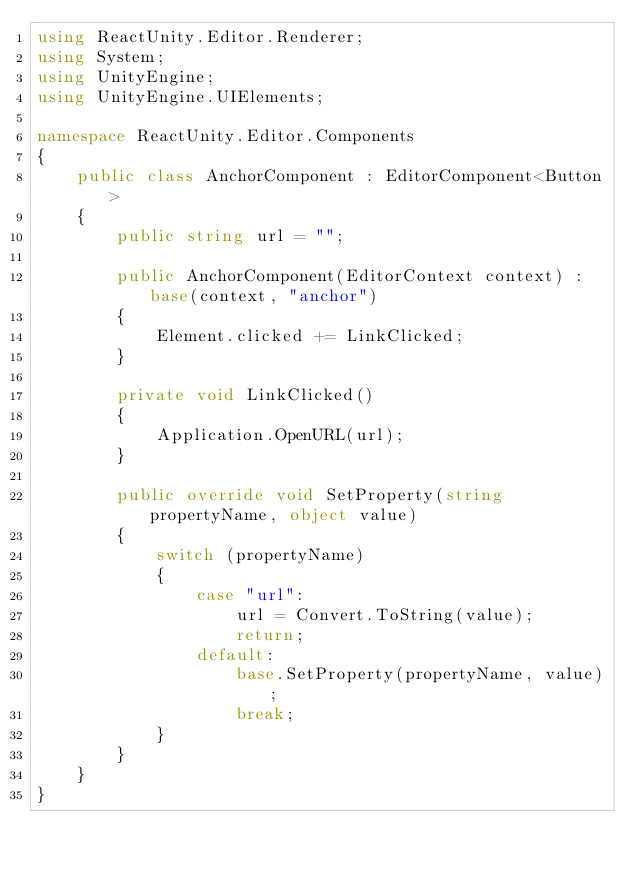<code> <loc_0><loc_0><loc_500><loc_500><_C#_>using ReactUnity.Editor.Renderer;
using System;
using UnityEngine;
using UnityEngine.UIElements;

namespace ReactUnity.Editor.Components
{
    public class AnchorComponent : EditorComponent<Button>
    {
        public string url = "";

        public AnchorComponent(EditorContext context) : base(context, "anchor")
        {
            Element.clicked += LinkClicked;
        }

        private void LinkClicked()
        {
            Application.OpenURL(url);
        }

        public override void SetProperty(string propertyName, object value)
        {
            switch (propertyName)
            {
                case "url":
                    url = Convert.ToString(value);
                    return;
                default:
                    base.SetProperty(propertyName, value);
                    break;
            }
        }
    }
}
</code> 